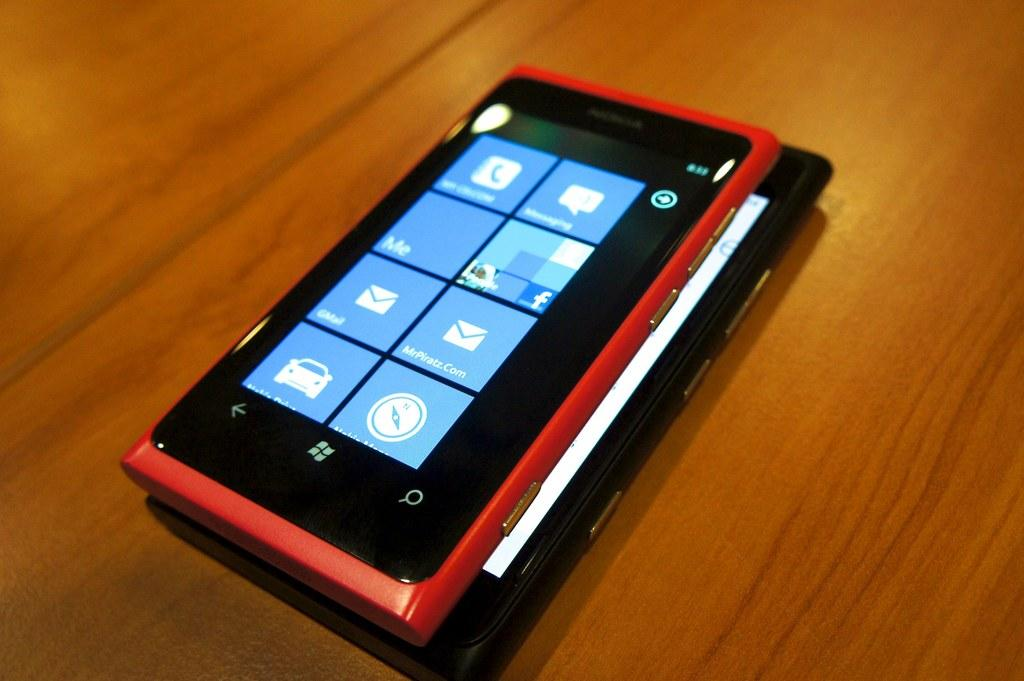<image>
Share a concise interpretation of the image provided. A windows phone and screen showing the menu on the phone 